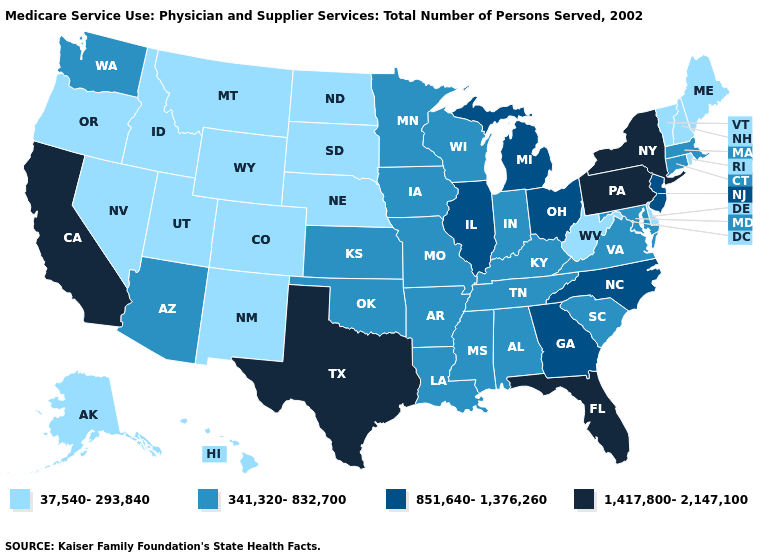Name the states that have a value in the range 851,640-1,376,260?
Concise answer only. Georgia, Illinois, Michigan, New Jersey, North Carolina, Ohio. What is the value of Georgia?
Concise answer only. 851,640-1,376,260. What is the lowest value in the USA?
Keep it brief. 37,540-293,840. What is the highest value in the USA?
Write a very short answer. 1,417,800-2,147,100. Which states hav the highest value in the MidWest?
Keep it brief. Illinois, Michigan, Ohio. Which states hav the highest value in the Northeast?
Short answer required. New York, Pennsylvania. Which states have the lowest value in the MidWest?
Keep it brief. Nebraska, North Dakota, South Dakota. Name the states that have a value in the range 1,417,800-2,147,100?
Keep it brief. California, Florida, New York, Pennsylvania, Texas. Name the states that have a value in the range 37,540-293,840?
Answer briefly. Alaska, Colorado, Delaware, Hawaii, Idaho, Maine, Montana, Nebraska, Nevada, New Hampshire, New Mexico, North Dakota, Oregon, Rhode Island, South Dakota, Utah, Vermont, West Virginia, Wyoming. What is the value of Ohio?
Short answer required. 851,640-1,376,260. Does the first symbol in the legend represent the smallest category?
Keep it brief. Yes. Name the states that have a value in the range 341,320-832,700?
Answer briefly. Alabama, Arizona, Arkansas, Connecticut, Indiana, Iowa, Kansas, Kentucky, Louisiana, Maryland, Massachusetts, Minnesota, Mississippi, Missouri, Oklahoma, South Carolina, Tennessee, Virginia, Washington, Wisconsin. Name the states that have a value in the range 851,640-1,376,260?
Be succinct. Georgia, Illinois, Michigan, New Jersey, North Carolina, Ohio. Does the map have missing data?
Write a very short answer. No. What is the value of South Dakota?
Keep it brief. 37,540-293,840. 